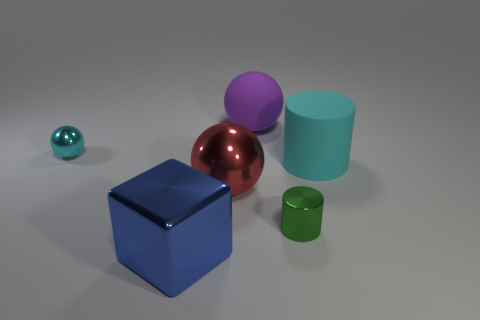How many blue things are either cubes or tiny rubber cylinders?
Your answer should be very brief. 1. Are there more tiny objects that are on the left side of the red metallic thing than large blue matte cubes?
Your answer should be compact. Yes. Is the cyan sphere the same size as the red shiny object?
Your answer should be compact. No. The other tiny thing that is made of the same material as the tiny green thing is what color?
Ensure brevity in your answer.  Cyan. There is a metal object that is the same color as the matte cylinder; what shape is it?
Keep it short and to the point. Sphere. Is the number of large metal things that are to the right of the green cylinder the same as the number of large blue cubes to the left of the large purple rubber thing?
Offer a terse response. No. There is a metal thing that is to the right of the large matte object on the left side of the big cyan cylinder; what shape is it?
Provide a succinct answer. Cylinder. There is another thing that is the same shape as the cyan rubber object; what is it made of?
Make the answer very short. Metal. What is the color of the block that is the same size as the red shiny object?
Ensure brevity in your answer.  Blue. Are there an equal number of big balls that are in front of the red object and red metallic things?
Provide a short and direct response. No. 